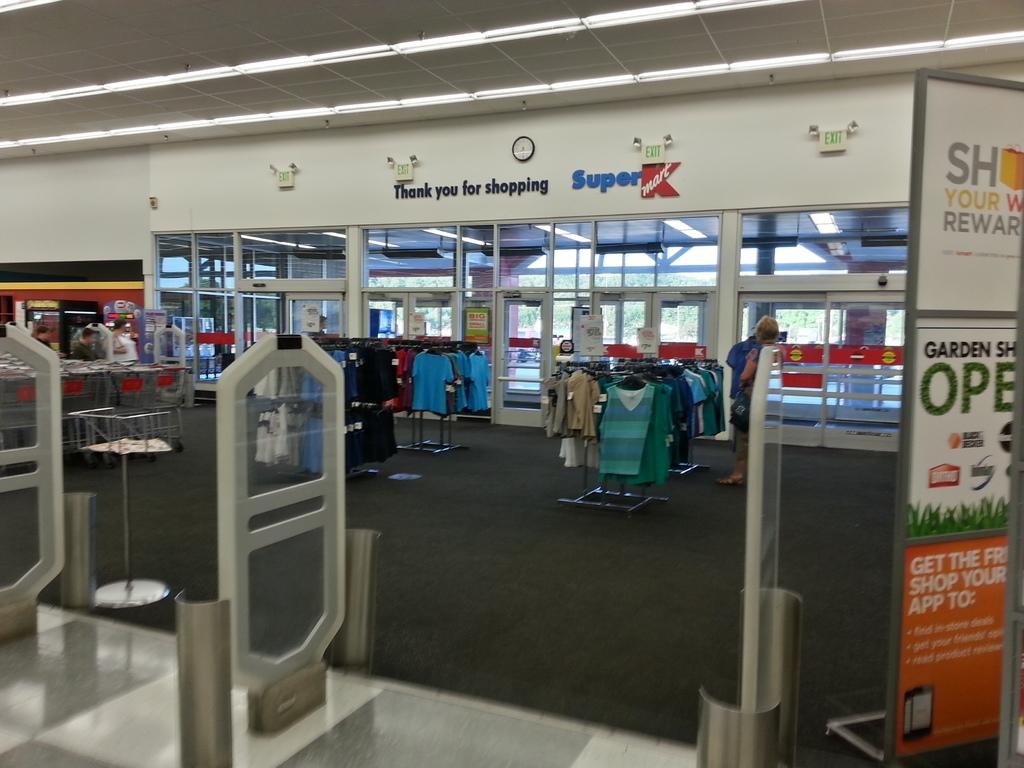Is this a super k-mart?
Provide a short and direct response. Yes. Thank you for what?
Offer a very short reply. Shopping. 